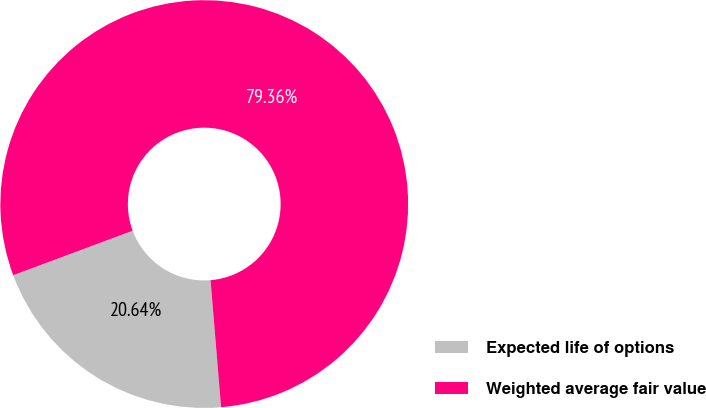Convert chart to OTSL. <chart><loc_0><loc_0><loc_500><loc_500><pie_chart><fcel>Expected life of options<fcel>Weighted average fair value<nl><fcel>20.64%<fcel>79.36%<nl></chart> 